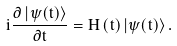Convert formula to latex. <formula><loc_0><loc_0><loc_500><loc_500>i \frac { \partial \left | \psi ( t ) \right \rangle } { \partial t } = H \left ( t \right ) \left | \psi ( t ) \right \rangle .</formula> 